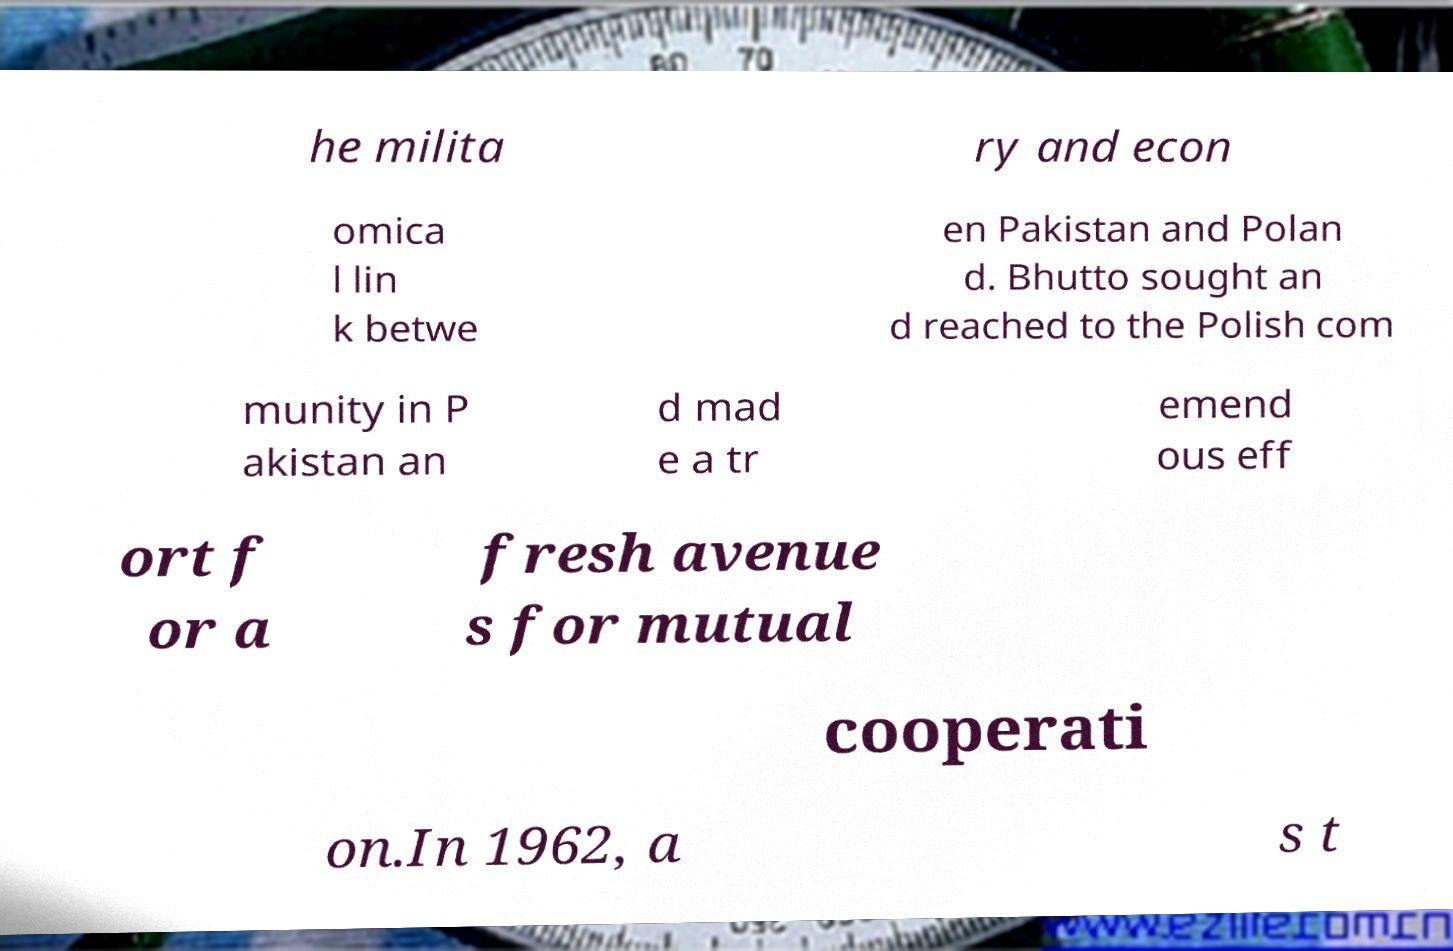Please read and relay the text visible in this image. What does it say? he milita ry and econ omica l lin k betwe en Pakistan and Polan d. Bhutto sought an d reached to the Polish com munity in P akistan an d mad e a tr emend ous eff ort f or a fresh avenue s for mutual cooperati on.In 1962, a s t 